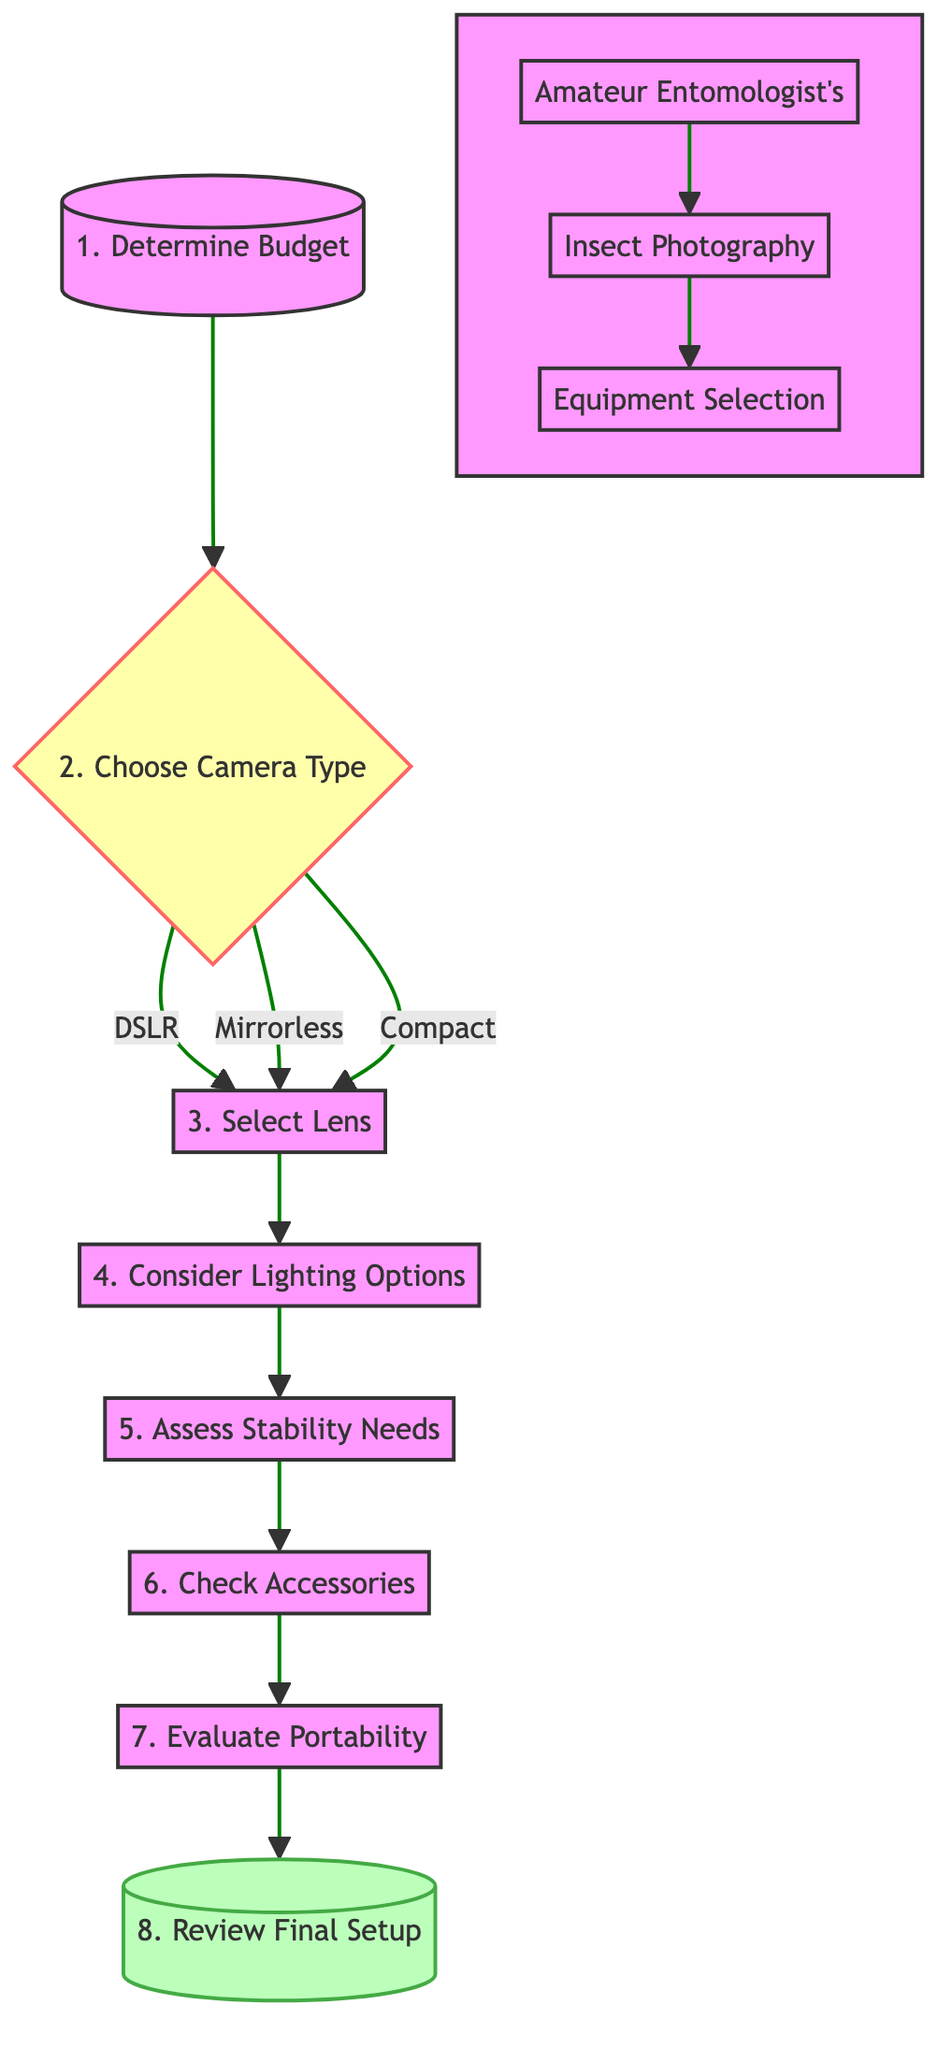What is the first step in selecting insect photography equipment? The first step in the flow chart is "Determine Budget," identified as node 1, which initiates the decision process.
Answer: Determine Budget How many camera types can you choose from in this diagram? In the flow chart, the "Choose Camera Type" decision node (node 2) indicates three options: DSLR, mirrorless, or compact camera.
Answer: Three Which node follows "Select Lens"? The flow chart shows that immediately after "Select Lens" (node 3), the next step is "Consider Lighting Options" (node 4).
Answer: Consider Lighting Options What does "Assess Stability Needs" entail in the decision process? "Assess Stability Needs" (node 5) refers to evaluating whether a tripod or stabilizer is required based on the specific shooting conditions being considered.
Answer: Tripod or Stabilizer What is the final step in the flow chart? The final step is represented as "Review Final Setup" (node 8), which refers to ensuring that all selected equipment satisfies the photographer's style and requirements.
Answer: Review Final Setup After determining the budget, which option can you choose for the camera type? Following "Determine Budget" (node 1), you move to "Choose Camera Type" (node 2), where you can select between a DSLR, mirrorless camera, or compact camera based on your preference.
Answer: DSLR, mirrorless, or compact How does the flow chart categorize the types of lenses? The diagram states "Select Lens" (node 3) for choosing among macro lenses or extension tubes, placing it clearly under the lens selection process after choosing the camera type.
Answer: Macro lens or extension tubes What is necessary to ensure before finalizing the setup? Before concluding the equipment selection process, it's vital to "Review Final Setup" (node 8), which focuses on verifying that all selected items align with the user’s photography style and needs.
Answer: Verification of compatibility What type of decisions are illustrated in the flow chart? The flow chart outlines a series of decision-making steps in selecting the right equipment for insect photography, indicating a structured process relying on evaluations and choices at each node.
Answer: Decision-making steps 